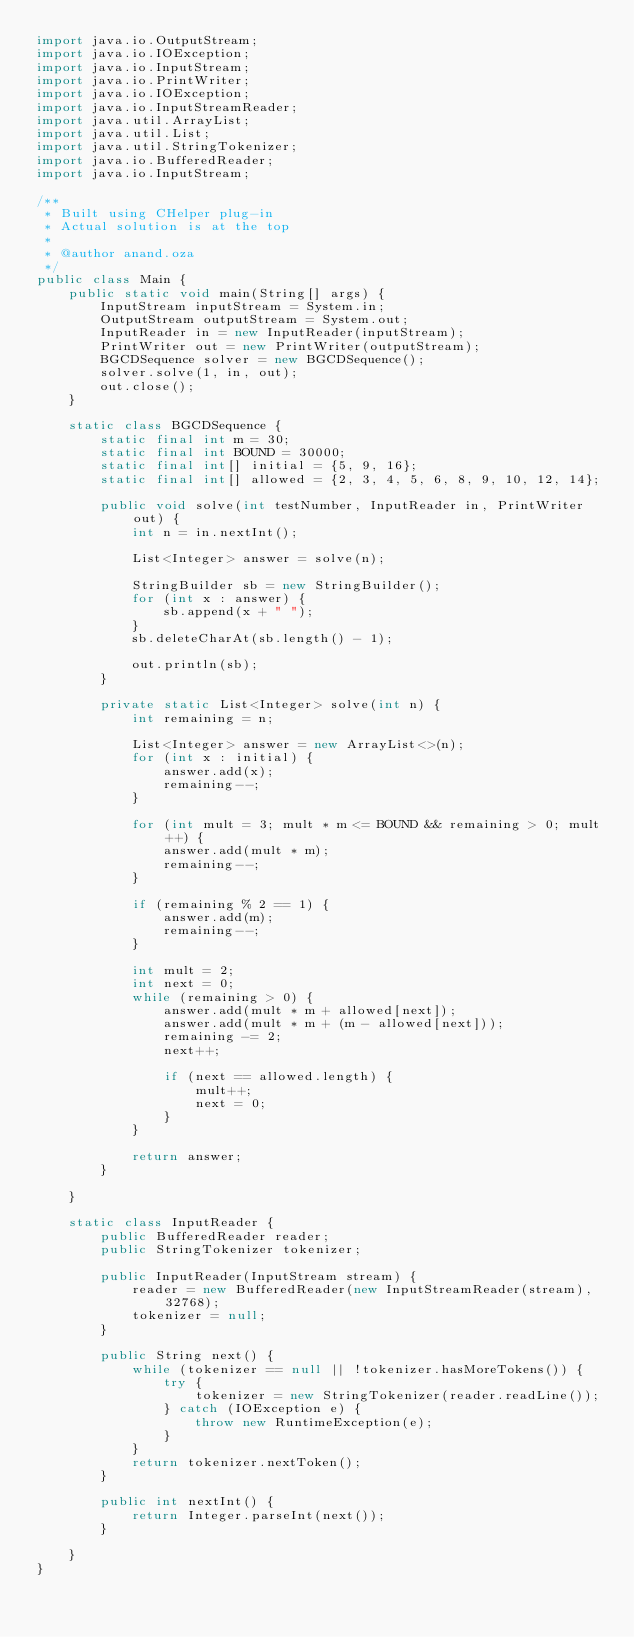<code> <loc_0><loc_0><loc_500><loc_500><_Java_>import java.io.OutputStream;
import java.io.IOException;
import java.io.InputStream;
import java.io.PrintWriter;
import java.io.IOException;
import java.io.InputStreamReader;
import java.util.ArrayList;
import java.util.List;
import java.util.StringTokenizer;
import java.io.BufferedReader;
import java.io.InputStream;

/**
 * Built using CHelper plug-in
 * Actual solution is at the top
 *
 * @author anand.oza
 */
public class Main {
    public static void main(String[] args) {
        InputStream inputStream = System.in;
        OutputStream outputStream = System.out;
        InputReader in = new InputReader(inputStream);
        PrintWriter out = new PrintWriter(outputStream);
        BGCDSequence solver = new BGCDSequence();
        solver.solve(1, in, out);
        out.close();
    }

    static class BGCDSequence {
        static final int m = 30;
        static final int BOUND = 30000;
        static final int[] initial = {5, 9, 16};
        static final int[] allowed = {2, 3, 4, 5, 6, 8, 9, 10, 12, 14};

        public void solve(int testNumber, InputReader in, PrintWriter out) {
            int n = in.nextInt();

            List<Integer> answer = solve(n);

            StringBuilder sb = new StringBuilder();
            for (int x : answer) {
                sb.append(x + " ");
            }
            sb.deleteCharAt(sb.length() - 1);

            out.println(sb);
        }

        private static List<Integer> solve(int n) {
            int remaining = n;

            List<Integer> answer = new ArrayList<>(n);
            for (int x : initial) {
                answer.add(x);
                remaining--;
            }

            for (int mult = 3; mult * m <= BOUND && remaining > 0; mult++) {
                answer.add(mult * m);
                remaining--;
            }

            if (remaining % 2 == 1) {
                answer.add(m);
                remaining--;
            }

            int mult = 2;
            int next = 0;
            while (remaining > 0) {
                answer.add(mult * m + allowed[next]);
                answer.add(mult * m + (m - allowed[next]));
                remaining -= 2;
                next++;

                if (next == allowed.length) {
                    mult++;
                    next = 0;
                }
            }

            return answer;
        }

    }

    static class InputReader {
        public BufferedReader reader;
        public StringTokenizer tokenizer;

        public InputReader(InputStream stream) {
            reader = new BufferedReader(new InputStreamReader(stream), 32768);
            tokenizer = null;
        }

        public String next() {
            while (tokenizer == null || !tokenizer.hasMoreTokens()) {
                try {
                    tokenizer = new StringTokenizer(reader.readLine());
                } catch (IOException e) {
                    throw new RuntimeException(e);
                }
            }
            return tokenizer.nextToken();
        }

        public int nextInt() {
            return Integer.parseInt(next());
        }

    }
}

</code> 